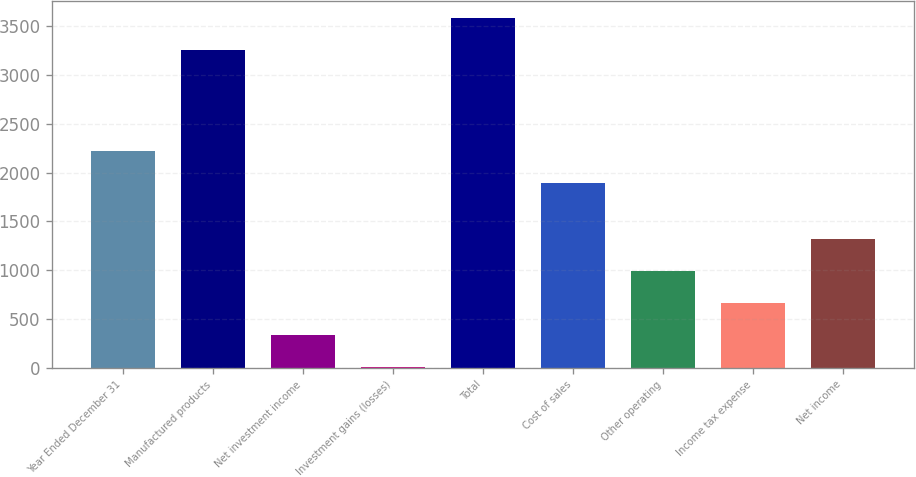<chart> <loc_0><loc_0><loc_500><loc_500><bar_chart><fcel>Year Ended December 31<fcel>Manufactured products<fcel>Net investment income<fcel>Investment gains (losses)<fcel>Total<fcel>Cost of sales<fcel>Other operating<fcel>Income tax expense<fcel>Net income<nl><fcel>2220.7<fcel>3255.6<fcel>337.3<fcel>9.7<fcel>3583.2<fcel>1893.1<fcel>992.5<fcel>664.9<fcel>1320.1<nl></chart> 